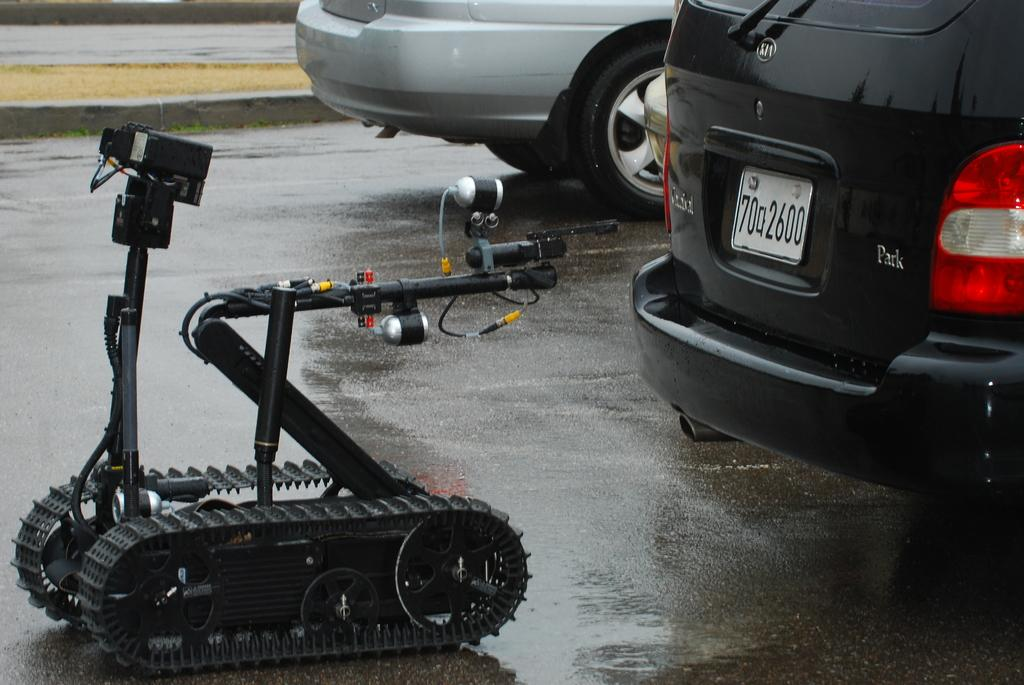What types of objects are present in the image? There are vehicles and an electronic machine in the image. Can you describe the electronic machine in the image? The electronic machine is black in color. Where are the vehicles and electronic machine located in the image? The vehicles and electronic machine are on the road. What type of rock is visible in the image? There is no rock present in the image; it features vehicles and an electronic machine on the road. What government policies are being discussed in the image? There is no discussion of government policies in the image; it only shows vehicles and an electronic machine on the road. 